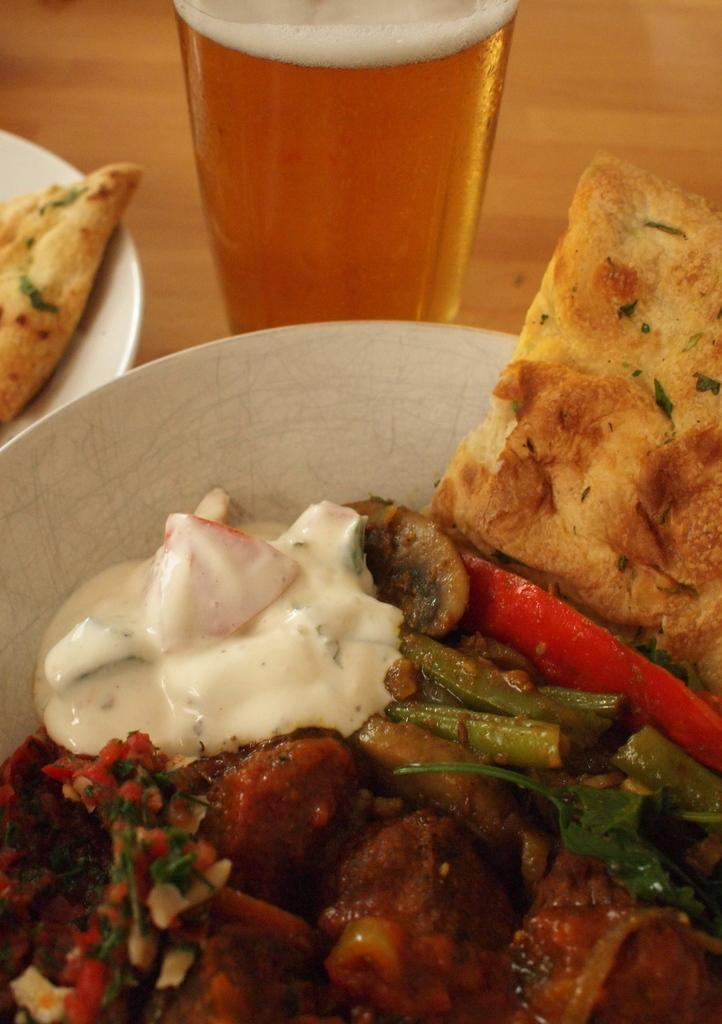What is on the plate that is visible in the image? There is a plate with food in the image. What else can be seen on a surface in the image? There is a glass of drink on a surface in the image. Are there any other plates with food in the image? Yes, there is another plate with food on the left side in the image. What type of zinc is present in the image? There is no zinc present in the image. Can you tell me how many basketballs are visible in the image? There are no basketballs visible in the image. 